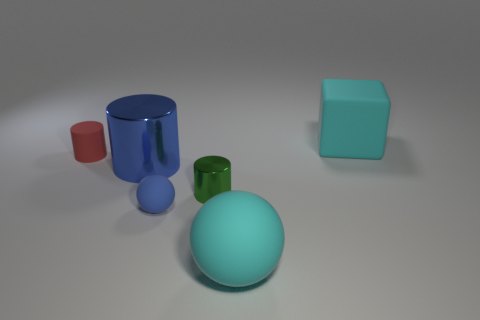Are there an equal number of big objects that are behind the tiny metal cylinder and large blue metallic cylinders right of the cyan sphere?
Your answer should be very brief. No. There is a ball in front of the blue ball; how big is it?
Provide a succinct answer. Large. Is the small matte cylinder the same color as the big rubber block?
Your answer should be very brief. No. Is there any other thing that has the same shape as the blue shiny thing?
Your answer should be compact. Yes. There is a large object that is the same color as the small ball; what is it made of?
Your answer should be compact. Metal. Are there the same number of matte cylinders in front of the big matte sphere and gray rubber cubes?
Ensure brevity in your answer.  Yes. Are there any blue rubber spheres on the left side of the big blue metal object?
Your answer should be very brief. No. There is a small blue object; is it the same shape as the cyan matte thing in front of the small blue sphere?
Offer a very short reply. Yes. What is the color of the large sphere that is made of the same material as the big cyan cube?
Give a very brief answer. Cyan. What color is the big metal object?
Give a very brief answer. Blue. 